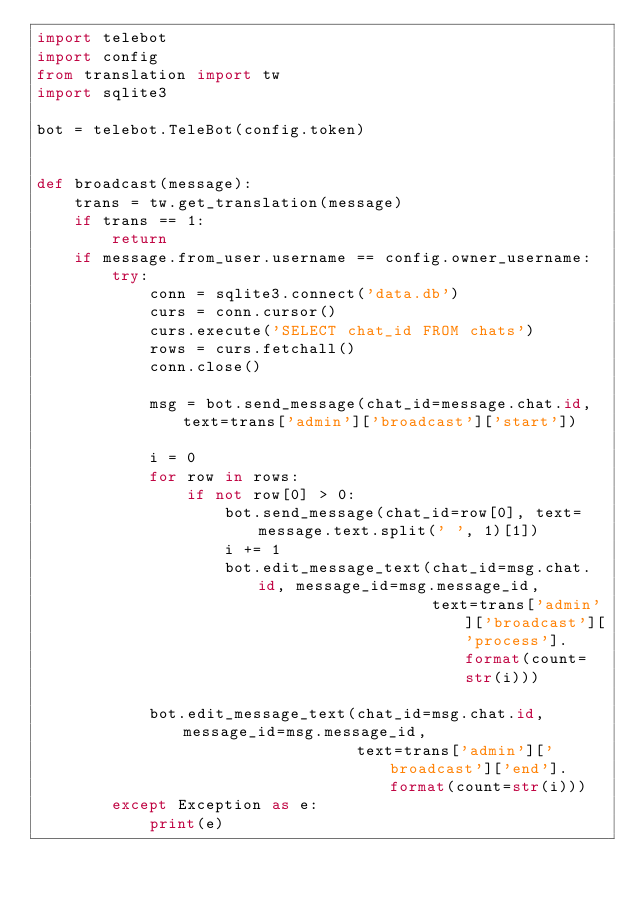Convert code to text. <code><loc_0><loc_0><loc_500><loc_500><_Python_>import telebot
import config
from translation import tw
import sqlite3

bot = telebot.TeleBot(config.token)


def broadcast(message):
    trans = tw.get_translation(message)
    if trans == 1:
        return
    if message.from_user.username == config.owner_username:
        try:
            conn = sqlite3.connect('data.db')
            curs = conn.cursor()
            curs.execute('SELECT chat_id FROM chats')
            rows = curs.fetchall()
            conn.close()

            msg = bot.send_message(chat_id=message.chat.id, text=trans['admin']['broadcast']['start'])

            i = 0
            for row in rows:
                if not row[0] > 0:
                    bot.send_message(chat_id=row[0], text=message.text.split(' ', 1)[1])
                    i += 1
                    bot.edit_message_text(chat_id=msg.chat.id, message_id=msg.message_id,
                                          text=trans['admin']['broadcast']['process'].format(count=str(i)))

            bot.edit_message_text(chat_id=msg.chat.id, message_id=msg.message_id,
                                  text=trans['admin']['broadcast']['end'].format(count=str(i)))
        except Exception as e:
            print(e)
</code> 